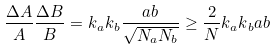Convert formula to latex. <formula><loc_0><loc_0><loc_500><loc_500>\frac { \Delta A } { A } \frac { \Delta B } { B } = k { _ { a } } k { _ { b } } \frac { a b } { \sqrt { N _ { a } N _ { b } } } \geq \frac { 2 } { N } k { _ { a } } k { _ { b } } a b</formula> 